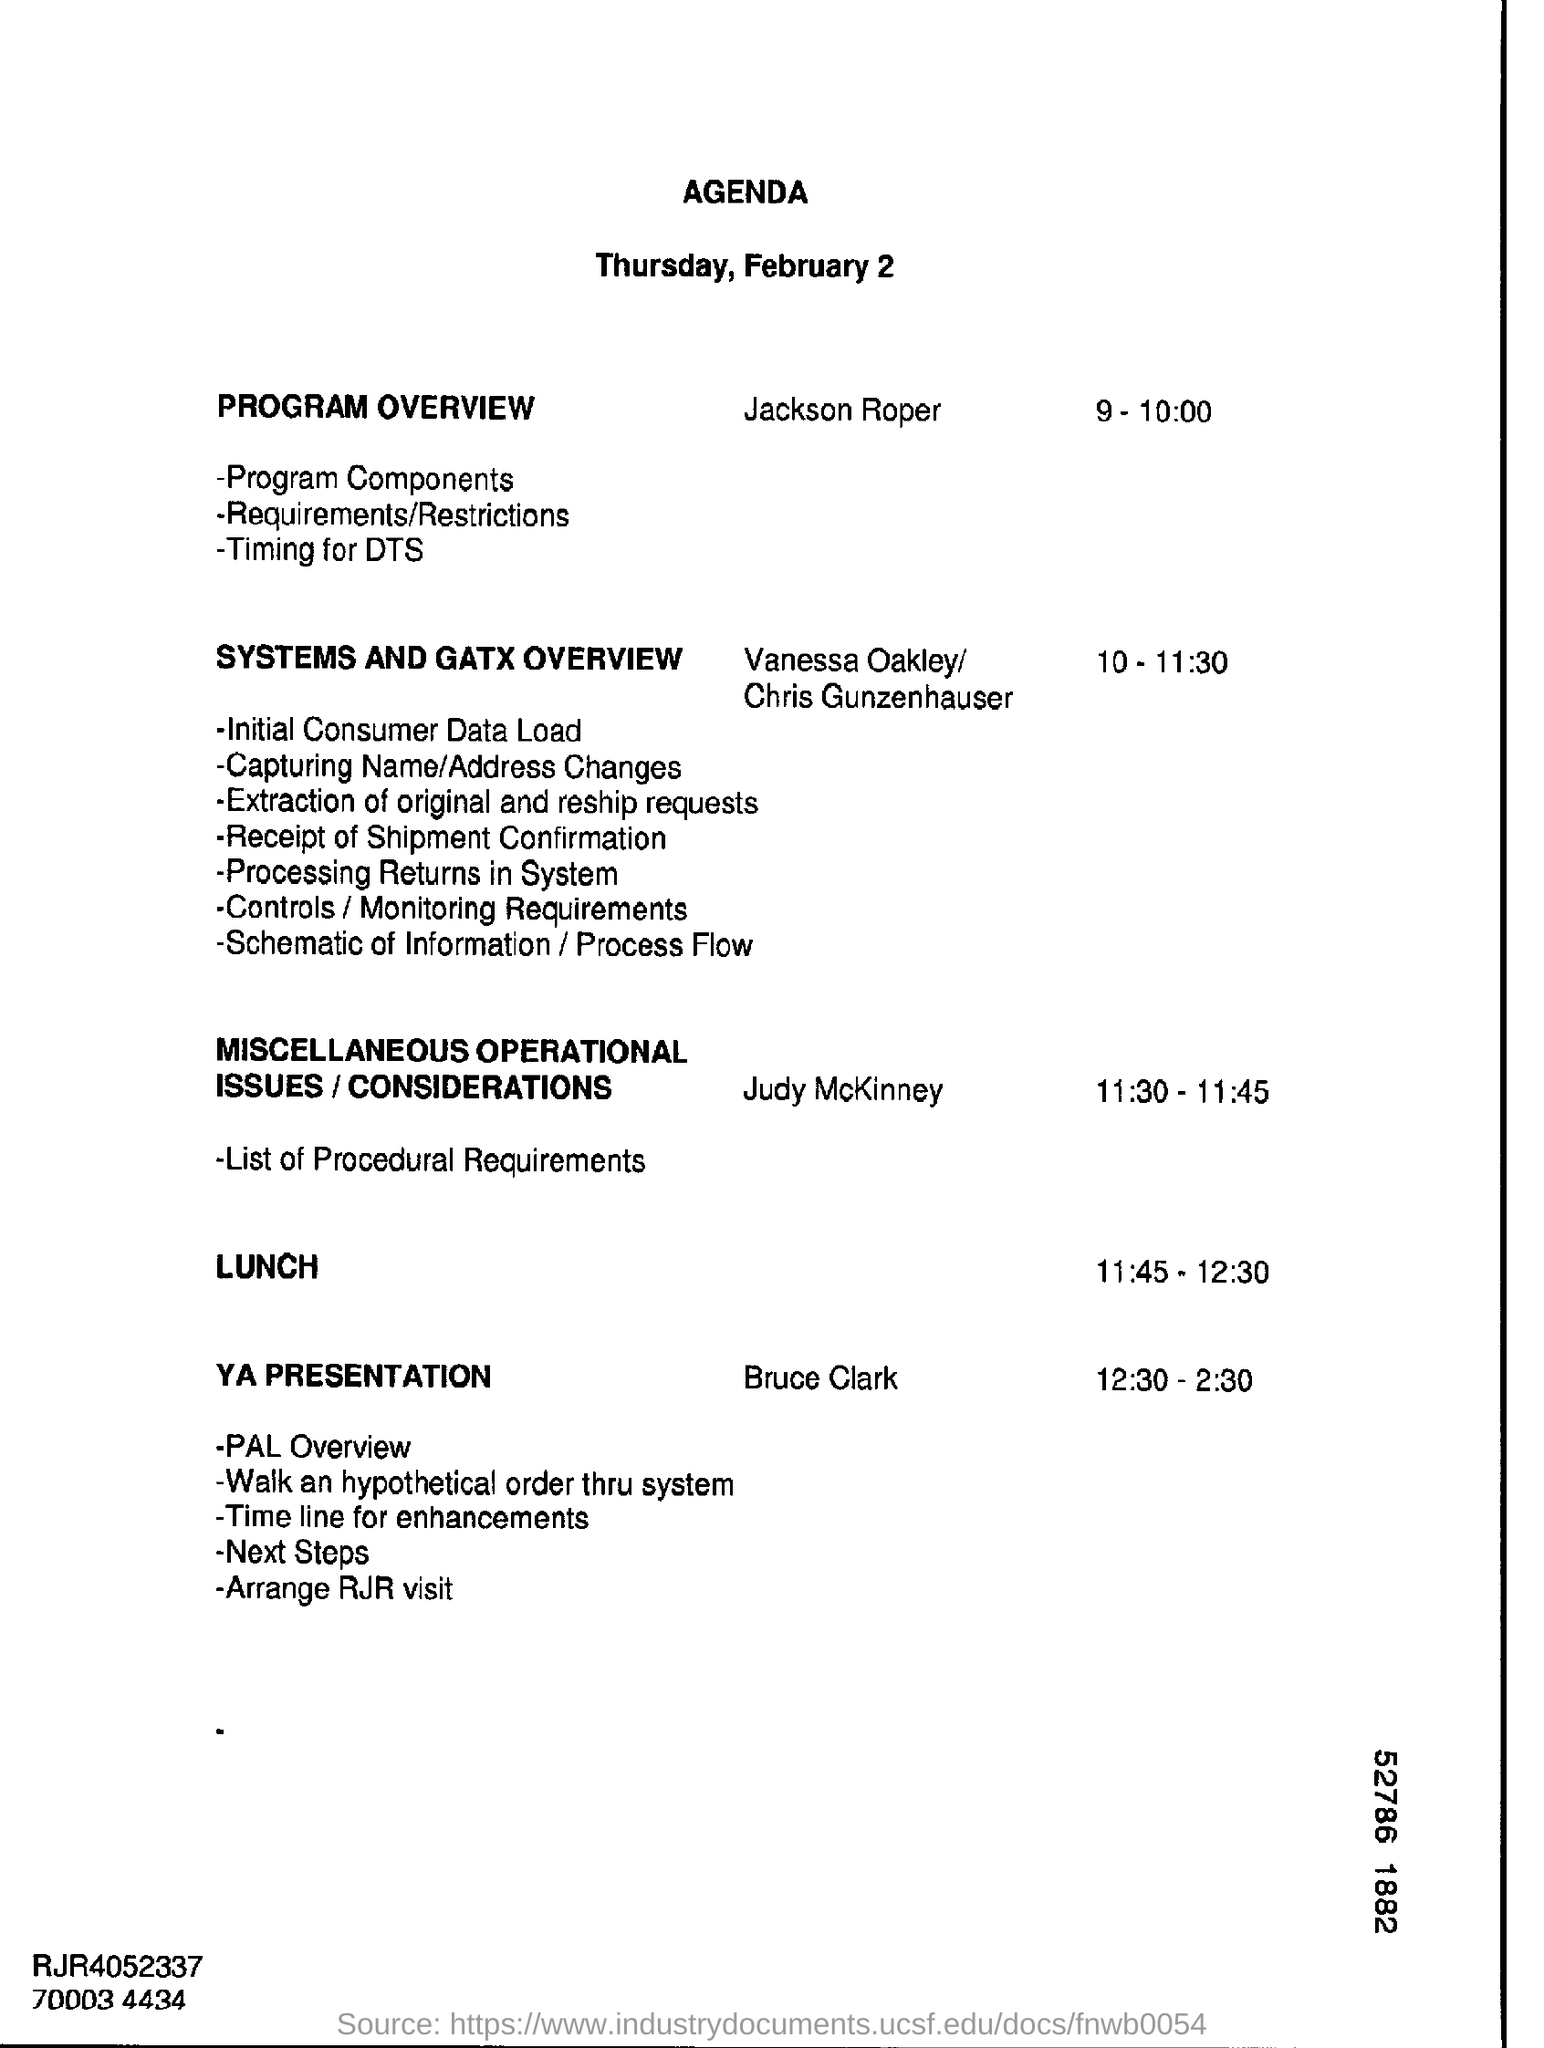Who is dealing with systems and gatx overview?
Give a very brief answer. Vanessa Oakley/ Chris Gunzenhauser. What is the date mentioned in the document?
Your answer should be very brief. February 2. 